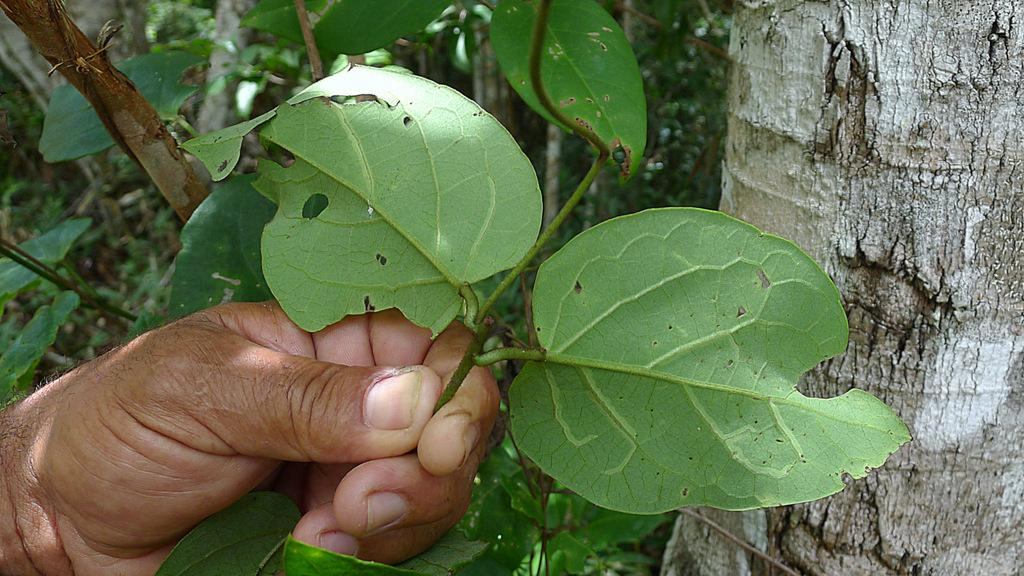What is the person holding in the image? There is a person's hand holding a stem with leaves in the image. What can be seen in the background of the image? There is bark and plants in the background of the image. What type of chicken is sitting on the person's shoulder in the image? There is no chicken present in the image; it only features a person's hand holding a stem with leaves and a background with bark and plants. 